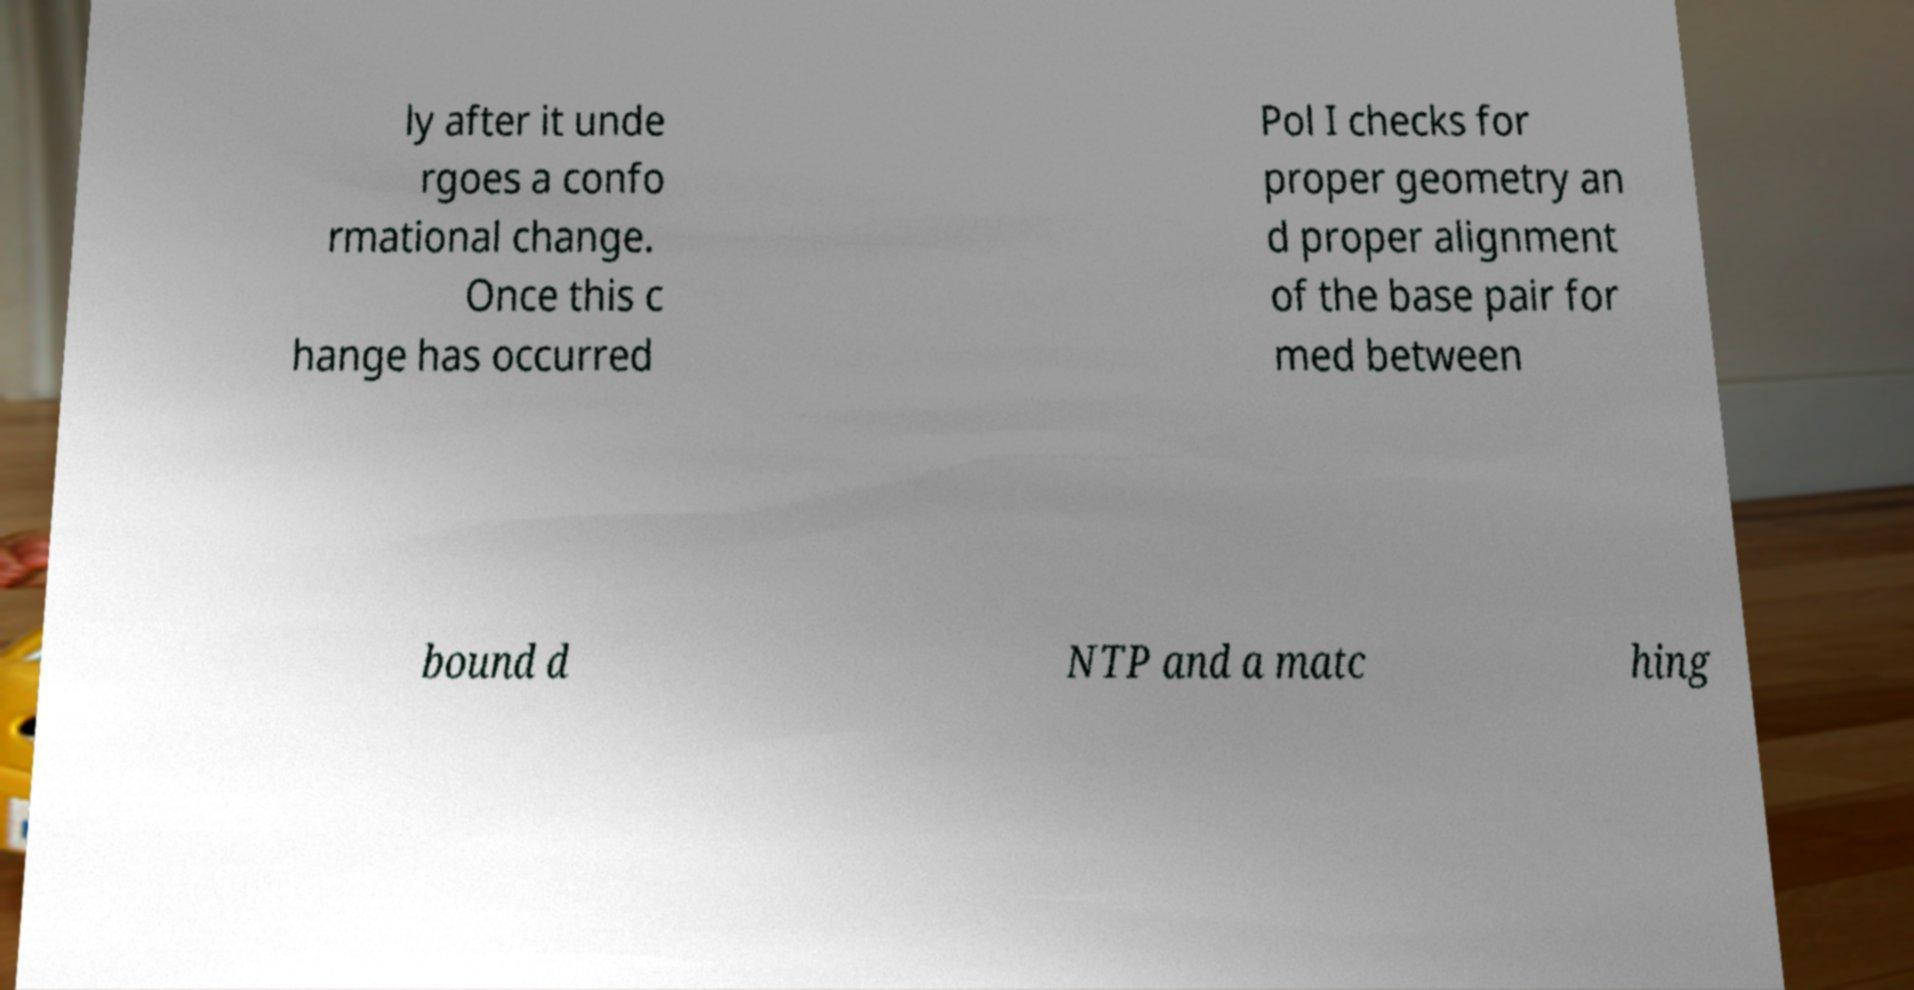What messages or text are displayed in this image? I need them in a readable, typed format. ly after it unde rgoes a confo rmational change. Once this c hange has occurred Pol I checks for proper geometry an d proper alignment of the base pair for med between bound d NTP and a matc hing 